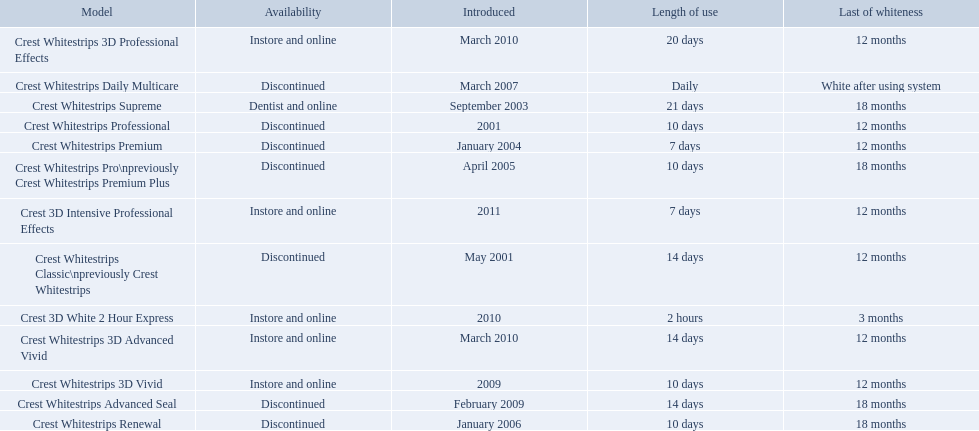What are all of the model names? Crest Whitestrips Classic\npreviously Crest Whitestrips, Crest Whitestrips Professional, Crest Whitestrips Supreme, Crest Whitestrips Premium, Crest Whitestrips Pro\npreviously Crest Whitestrips Premium Plus, Crest Whitestrips Renewal, Crest Whitestrips Daily Multicare, Crest Whitestrips Advanced Seal, Crest Whitestrips 3D Vivid, Crest Whitestrips 3D Advanced Vivid, Crest Whitestrips 3D Professional Effects, Crest 3D White 2 Hour Express, Crest 3D Intensive Professional Effects. When were they first introduced? May 2001, 2001, September 2003, January 2004, April 2005, January 2006, March 2007, February 2009, 2009, March 2010, March 2010, 2010, 2011. Along with crest whitestrips 3d advanced vivid, which other model was introduced in march 2010? Crest Whitestrips 3D Professional Effects. Which of these products are discontinued? Crest Whitestrips Classic\npreviously Crest Whitestrips, Crest Whitestrips Professional, Crest Whitestrips Premium, Crest Whitestrips Pro\npreviously Crest Whitestrips Premium Plus, Crest Whitestrips Renewal, Crest Whitestrips Daily Multicare, Crest Whitestrips Advanced Seal. Which of these products have a 14 day length of use? Crest Whitestrips Classic\npreviously Crest Whitestrips, Crest Whitestrips Advanced Seal. Which of these products was introduced in 2009? Crest Whitestrips Advanced Seal. 